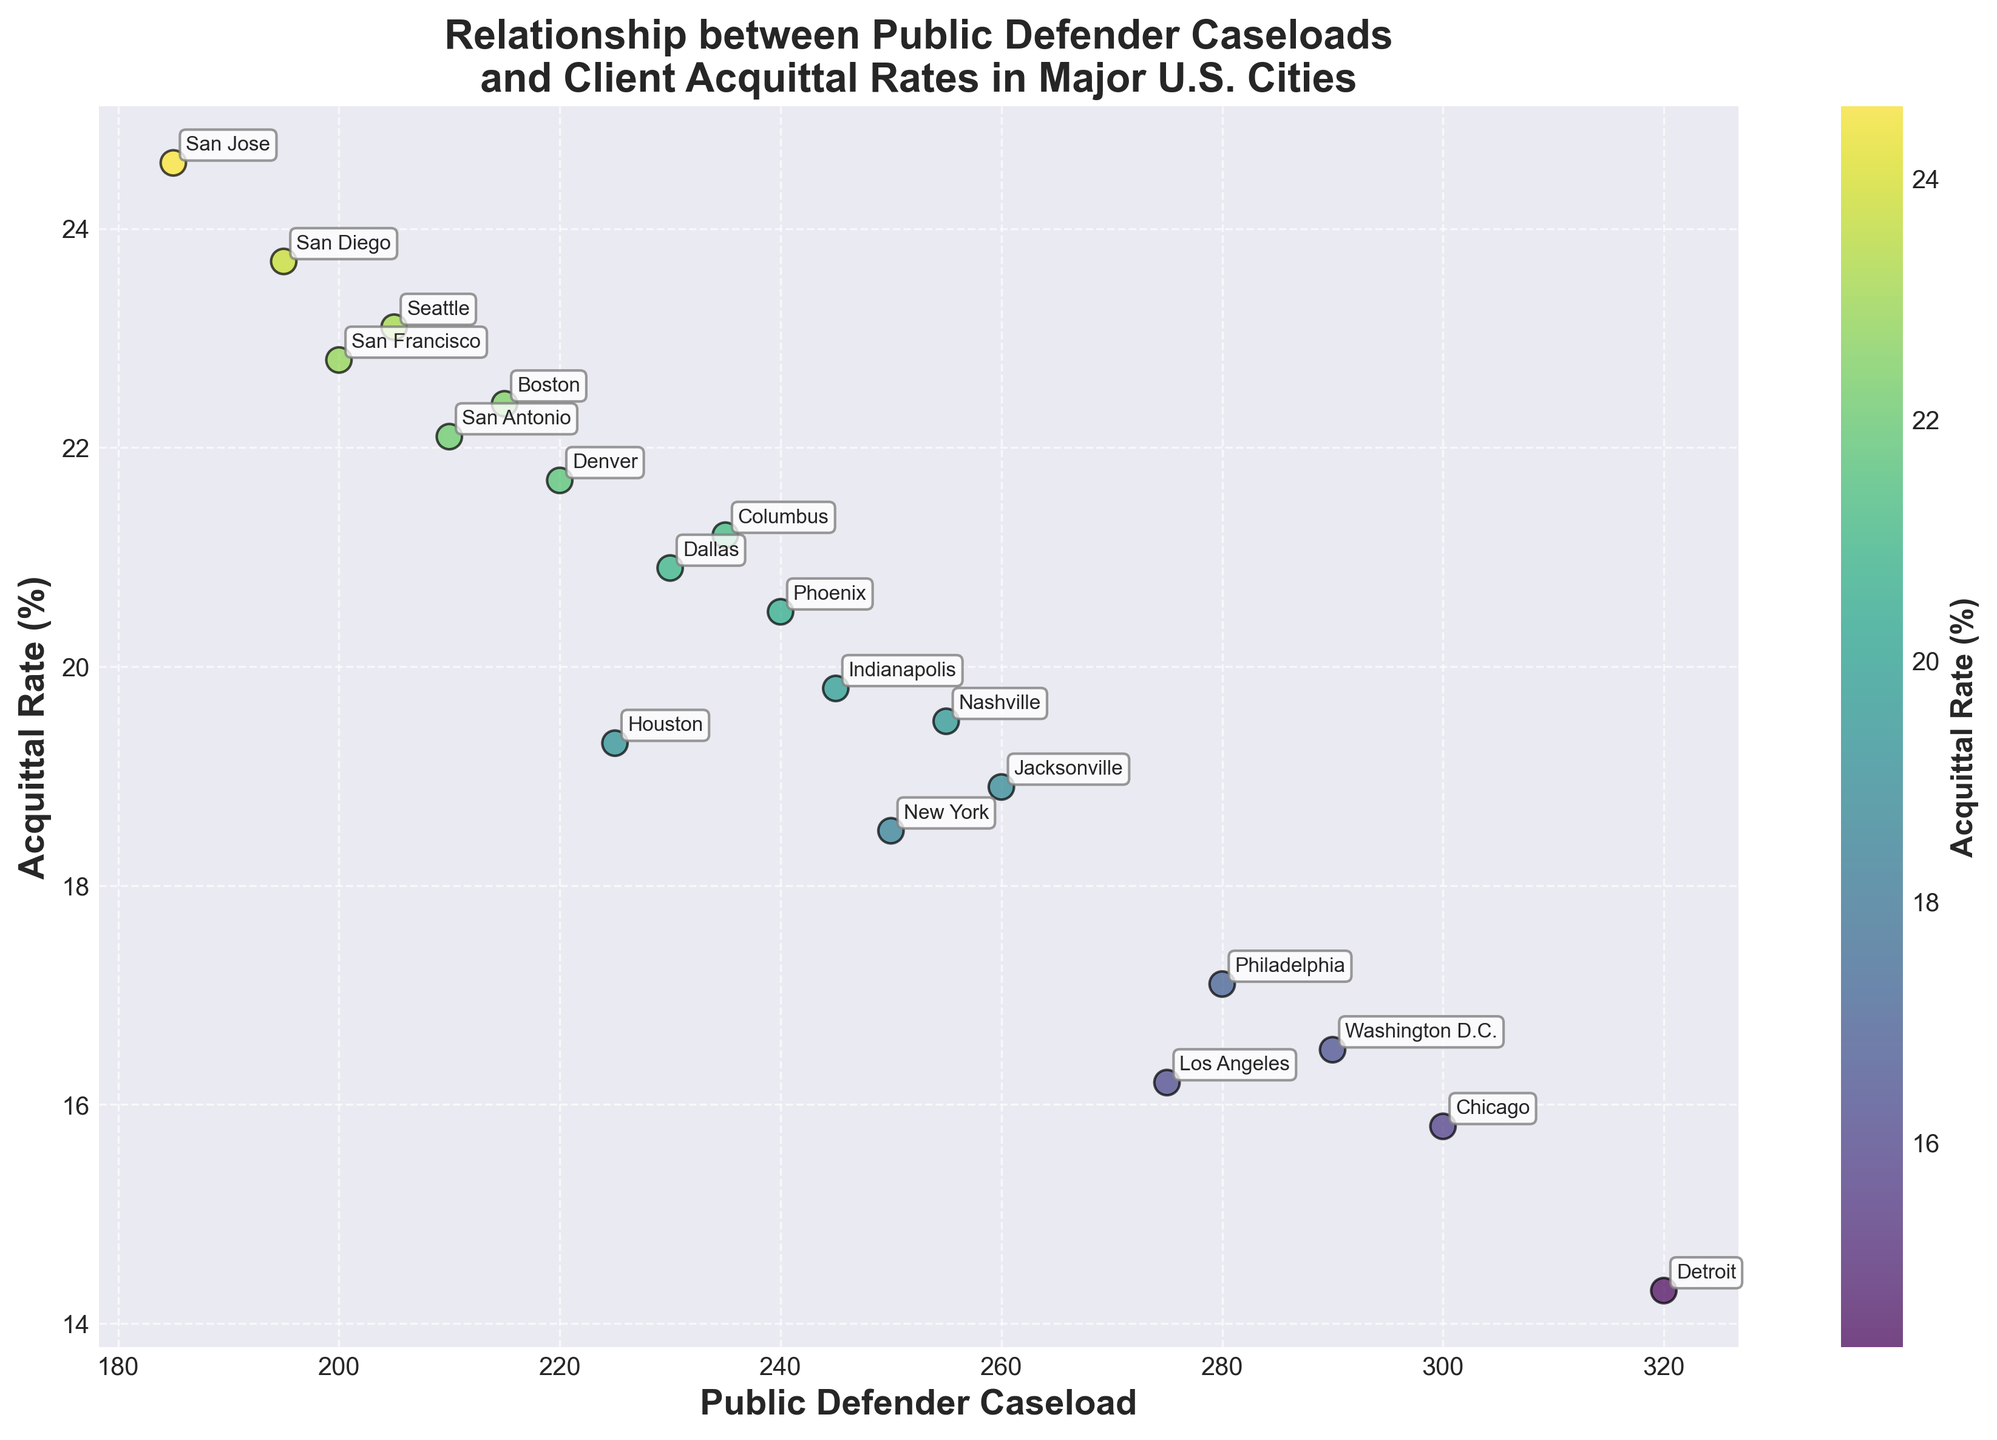What is the title of the plot? The title is located at the top of the plot, centered and in bold text
Answer: Relationship between Public Defender Caseloads and Client Acquittal Rates in Major U.S. Cities What are the labels on the x-axis and y-axis? The x-axis and y-axis labels are positioned along their respective axes and written in bold
Answer: Public Defender Caseload (x-axis), Acquittal Rate (%) (y-axis) How many data points are represented in the plot? The number of cities listed in the data corresponds to the number of data points in the scatter plot
Answer: 19 Which city has the highest acquittal rate? By examining the vertical position of the data points and corresponding labels, San Jose at the top has the highest acquittal rate
Answer: San Jose Which city has the highest public defender caseload? By examining the horizontal position of the data points and corresponding labels, Detroit has the furthest right position
Answer: Detroit What is the acquittal rate for New York? Locate New York on the scatter plot and check its vertical position relative to the y-axis
Answer: 18.5% What is the difference in acquittal rates between Houston and Los Angeles? Locate both cities on the plot, read their acquittal rates: 19.3% for Houston and 16.2% for Los Angeles. Subtract 16.2 from 19.3
Answer: 3.1% How many cities have an acquittal rate above 20%? Count the data points situated above the 20% mark on the y-axis
Answer: 8 Which city has a higher acquittal rate, Boston or Chicago? Locate both cities on the scatter plot and compare their vertical positions, Boston is higher than Chicago
Answer: Boston What is the correlation between public defender caseloads and acquittal rates in the dataset? Observe the overall trend of the data points; as caseload increases, acquittal rates seem to decrease
Answer: Negative correlation 